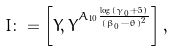Convert formula to latex. <formula><loc_0><loc_0><loc_500><loc_500>I \colon = \left [ Y , Y ^ { A _ { 1 0 } \frac { \log ( \gamma _ { 0 } + 5 ) } { ( \beta _ { 0 } - \theta ) ^ { 2 } } } \right ] ,</formula> 